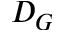<formula> <loc_0><loc_0><loc_500><loc_500>D _ { G }</formula> 